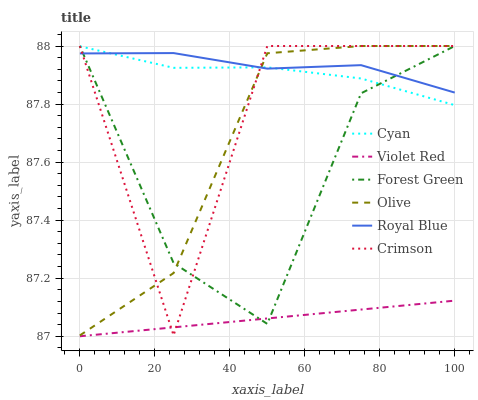Does Violet Red have the minimum area under the curve?
Answer yes or no. Yes. Does Royal Blue have the maximum area under the curve?
Answer yes or no. Yes. Does Crimson have the minimum area under the curve?
Answer yes or no. No. Does Crimson have the maximum area under the curve?
Answer yes or no. No. Is Violet Red the smoothest?
Answer yes or no. Yes. Is Crimson the roughest?
Answer yes or no. Yes. Is Royal Blue the smoothest?
Answer yes or no. No. Is Royal Blue the roughest?
Answer yes or no. No. Does Violet Red have the lowest value?
Answer yes or no. Yes. Does Crimson have the lowest value?
Answer yes or no. No. Does Olive have the highest value?
Answer yes or no. Yes. Does Royal Blue have the highest value?
Answer yes or no. No. Is Violet Red less than Royal Blue?
Answer yes or no. Yes. Is Royal Blue greater than Violet Red?
Answer yes or no. Yes. Does Crimson intersect Royal Blue?
Answer yes or no. Yes. Is Crimson less than Royal Blue?
Answer yes or no. No. Is Crimson greater than Royal Blue?
Answer yes or no. No. Does Violet Red intersect Royal Blue?
Answer yes or no. No. 